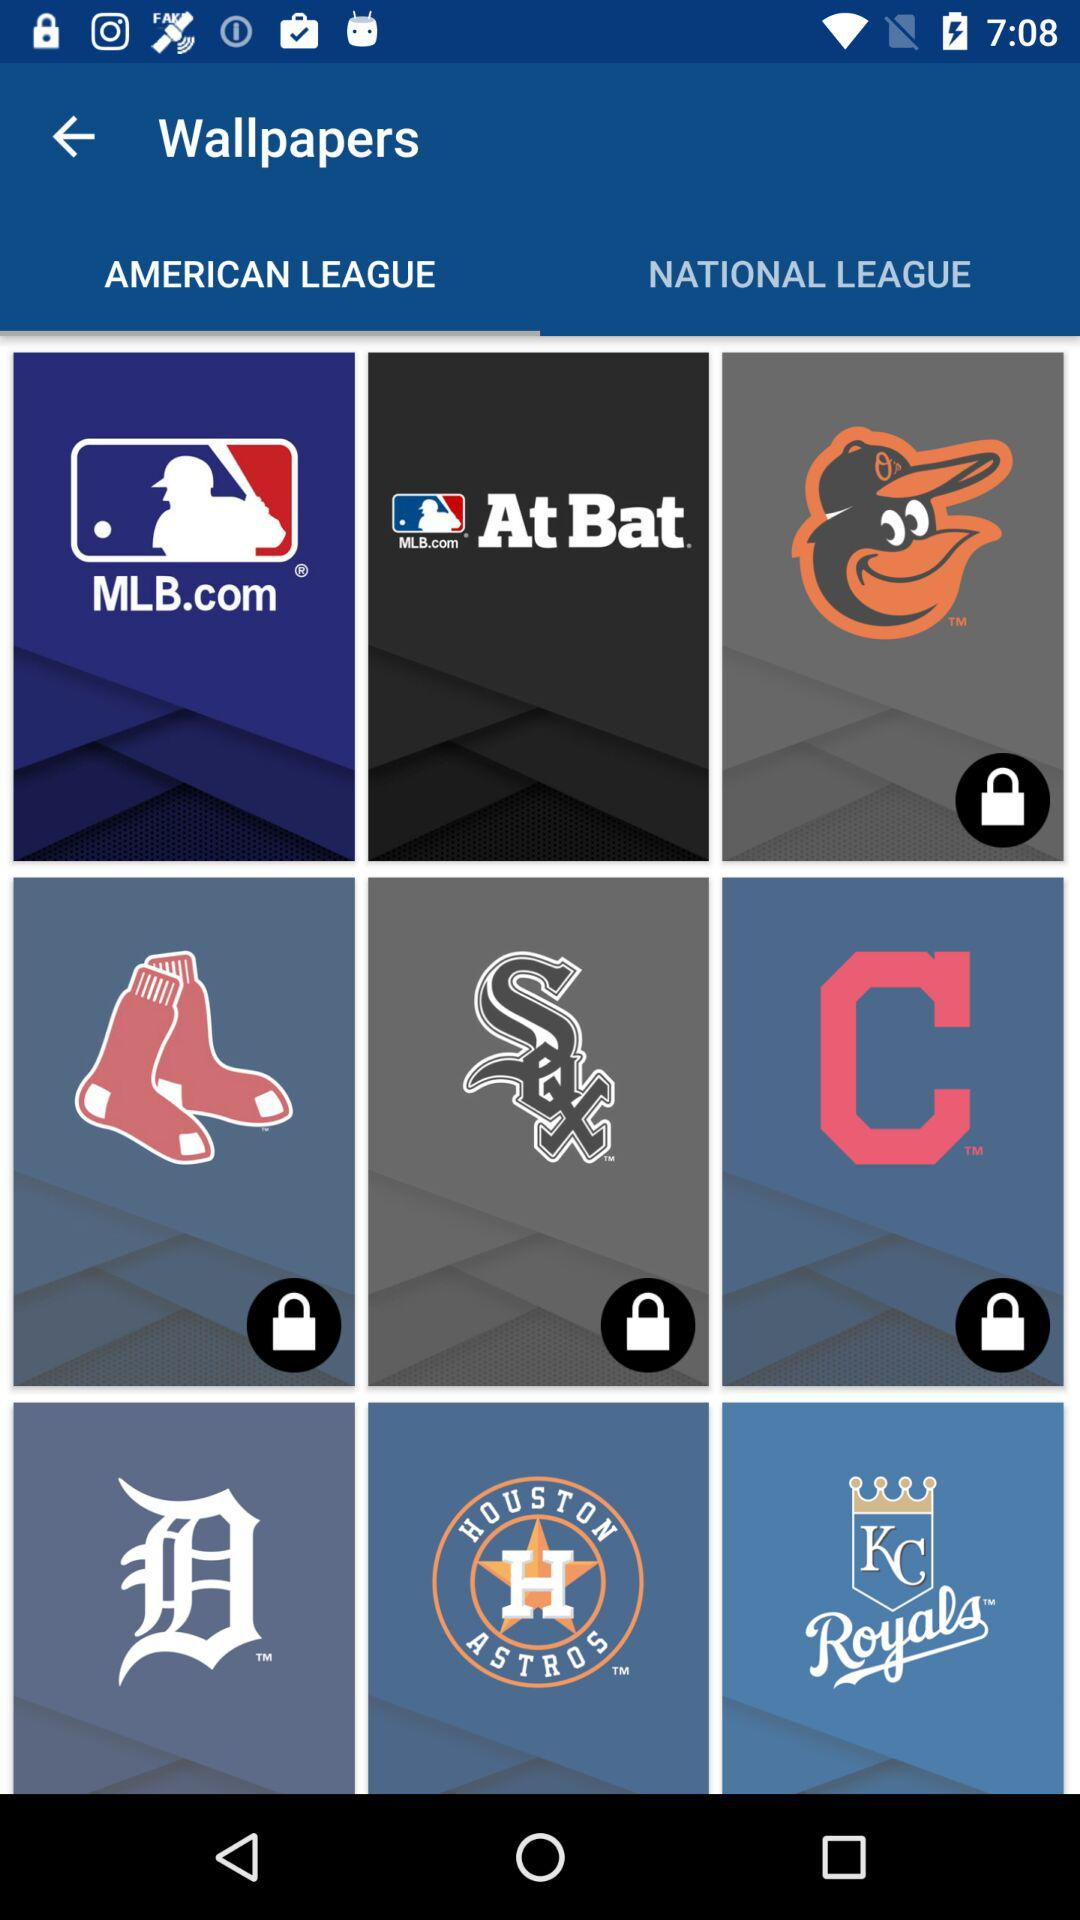Which teams are in the National League?
When the provided information is insufficient, respond with <no answer>. <no answer> 